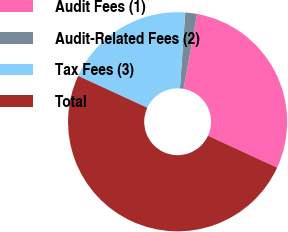Convert chart. <chart><loc_0><loc_0><loc_500><loc_500><pie_chart><fcel>Audit Fees (1)<fcel>Audit-Related Fees (2)<fcel>Tax Fees (3)<fcel>Total<nl><fcel>29.04%<fcel>1.73%<fcel>19.23%<fcel>50.0%<nl></chart> 